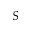<formula> <loc_0><loc_0><loc_500><loc_500>S</formula> 